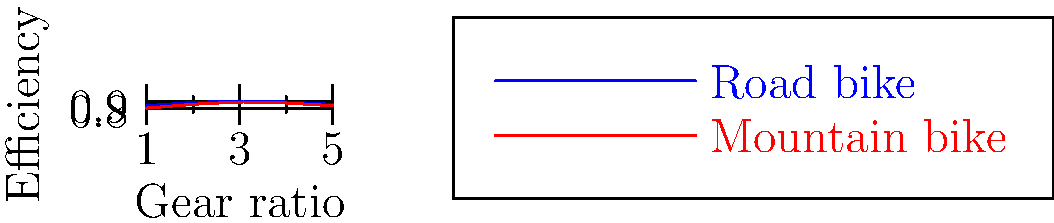As a math teacher and former soccer player, you understand the importance of efficiency in sports equipment. The graph shows the efficiency of different gear ratios for road and mountain bikes used in cross-training. If a student wants to maximize efficiency for both types of bikes, which gear ratio should they choose, and what is the average efficiency at this ratio? Let's approach this step-by-step:

1) First, we need to identify the point where both bikes have their highest combined efficiency. This occurs where the two lines are closest together at their peak.

2) Visually, we can see this occurs at a gear ratio of 3.

3) To find the efficiency for each bike at this ratio:
   - Road bike (blue line): approximately 0.95
   - Mountain bike (red line): approximately 0.93

4) To calculate the average efficiency:
   $$ \text{Average Efficiency} = \frac{\text{Road Bike Efficiency} + \text{Mountain Bike Efficiency}}{2} $$
   $$ = \frac{0.95 + 0.93}{2} = \frac{1.88}{2} = 0.94 $$

5) Therefore, the gear ratio that maximizes efficiency for both types of bikes is 3, with an average efficiency of 0.94 or 94%.

This solution combines our understanding of graphical analysis (a key skill in math) with practical applications in sports equipment (relating to your background in soccer and interest in cross-training).
Answer: Gear ratio: 3, Average efficiency: 0.94 (94%) 